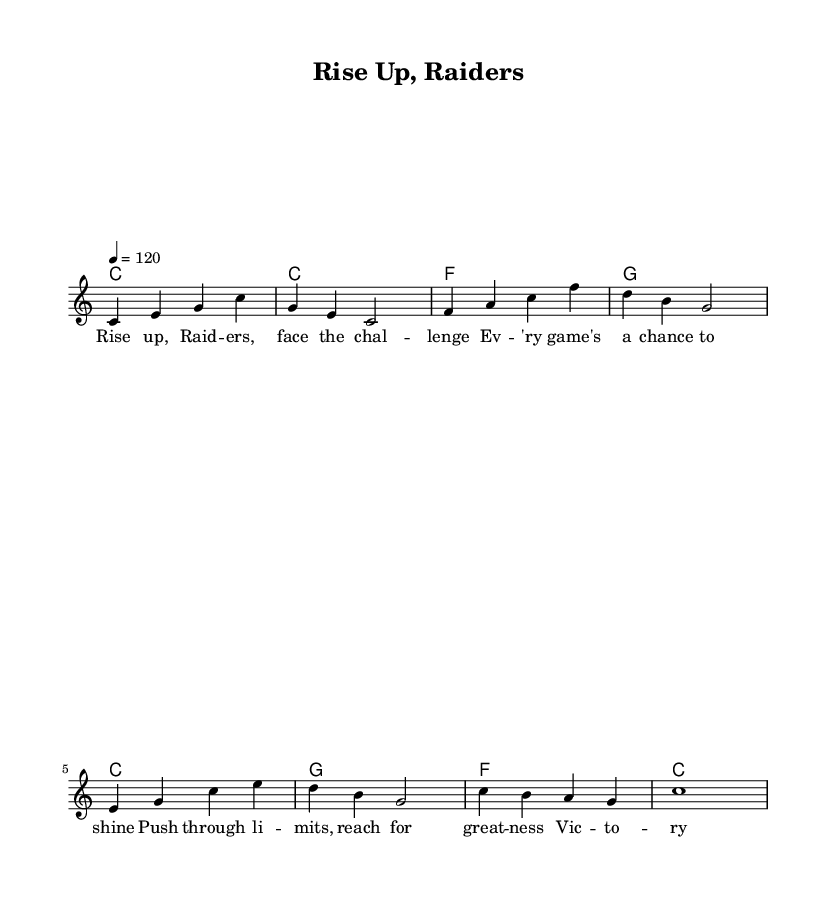What is the key signature of this music? The key signature is indicated at the beginning of the sheet music, where it shows that there are no sharps or flats. This corresponds to C major.
Answer: C major What is the time signature of this music? The time signature is written at the start of the sheet music and is indicated as 4/4, meaning there are four beats in a measure, and the quarter note gets one beat.
Answer: 4/4 What is the tempo marking of this music? The tempo marking can be found in the score, indicated as "4 = 120," which refers to a quarter note being played at a rate of 120 beats per minute.
Answer: 120 How many measures are in the melody? By counting the segments in the melody line, we can see that there are 8 measures total, as defined by the vertical lines dividing the music.
Answer: 8 Which chord is played in the first measure? The first measure shows a whole note C, which suggests the chord played is C major for the entire duration of that measure.
Answer: C What is the lyrical theme of the song? By looking at the lyrics written below the melody, we can determine that the theme focuses on motivation and overcoming challenges, emphasizing perseverance and achieving victory.
Answer: Motivation Which note is held for the entire last measure of the melody? The last measure contains a single note that is a whole note C, meaning it is held for the entire duration of that measure.
Answer: C 